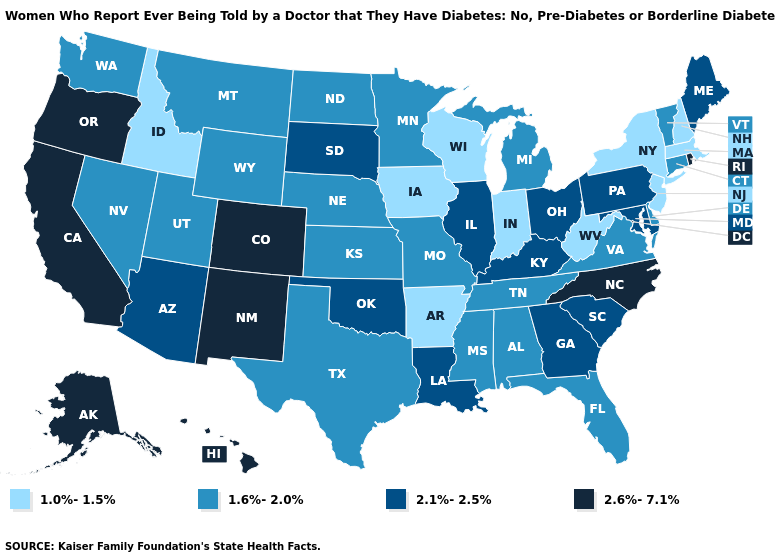Name the states that have a value in the range 1.6%-2.0%?
Quick response, please. Alabama, Connecticut, Delaware, Florida, Kansas, Michigan, Minnesota, Mississippi, Missouri, Montana, Nebraska, Nevada, North Dakota, Tennessee, Texas, Utah, Vermont, Virginia, Washington, Wyoming. Does the first symbol in the legend represent the smallest category?
Be succinct. Yes. How many symbols are there in the legend?
Answer briefly. 4. Name the states that have a value in the range 1.6%-2.0%?
Answer briefly. Alabama, Connecticut, Delaware, Florida, Kansas, Michigan, Minnesota, Mississippi, Missouri, Montana, Nebraska, Nevada, North Dakota, Tennessee, Texas, Utah, Vermont, Virginia, Washington, Wyoming. Which states have the lowest value in the West?
Give a very brief answer. Idaho. Name the states that have a value in the range 1.6%-2.0%?
Short answer required. Alabama, Connecticut, Delaware, Florida, Kansas, Michigan, Minnesota, Mississippi, Missouri, Montana, Nebraska, Nevada, North Dakota, Tennessee, Texas, Utah, Vermont, Virginia, Washington, Wyoming. What is the value of Alaska?
Write a very short answer. 2.6%-7.1%. Among the states that border Ohio , does Pennsylvania have the lowest value?
Be succinct. No. What is the highest value in the South ?
Give a very brief answer. 2.6%-7.1%. What is the lowest value in the USA?
Short answer required. 1.0%-1.5%. Name the states that have a value in the range 1.6%-2.0%?
Write a very short answer. Alabama, Connecticut, Delaware, Florida, Kansas, Michigan, Minnesota, Mississippi, Missouri, Montana, Nebraska, Nevada, North Dakota, Tennessee, Texas, Utah, Vermont, Virginia, Washington, Wyoming. Which states have the lowest value in the West?
Answer briefly. Idaho. Does California have the highest value in the USA?
Be succinct. Yes. Name the states that have a value in the range 2.6%-7.1%?
Short answer required. Alaska, California, Colorado, Hawaii, New Mexico, North Carolina, Oregon, Rhode Island. 